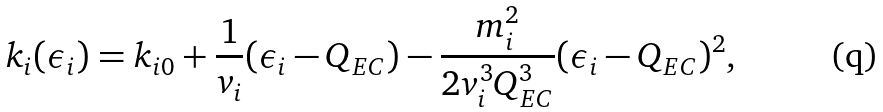Convert formula to latex. <formula><loc_0><loc_0><loc_500><loc_500>k _ { i } ( \epsilon _ { i } ) = k _ { i 0 } + \frac { 1 } { v _ { i } } ( \epsilon _ { i } - Q _ { E C } ) - \frac { m ^ { 2 } _ { i } } { 2 v ^ { 3 } _ { i } Q ^ { 3 } _ { E C } } ( \epsilon _ { i } - Q _ { E C } ) ^ { 2 } ,</formula> 